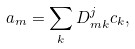<formula> <loc_0><loc_0><loc_500><loc_500>a _ { m } = \sum _ { k } D ^ { j } _ { m k } c _ { k } ,</formula> 